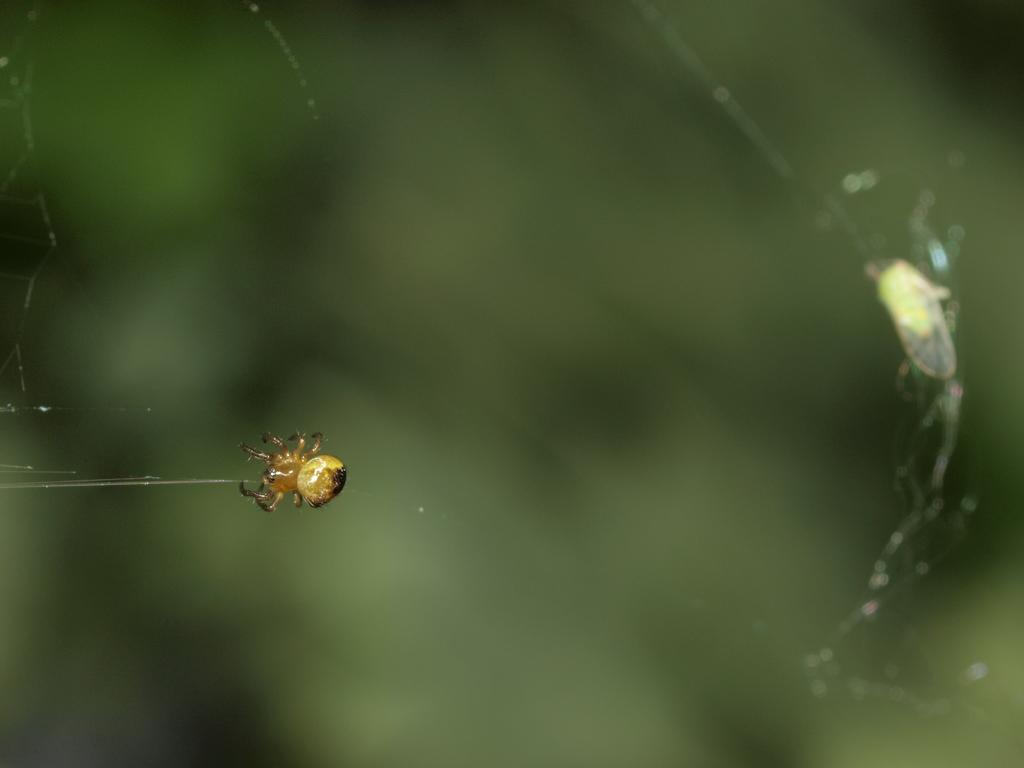What is the main subject of the image? There is a spider in the image. Where is the spider located? The spider is on a web. Can you describe the background of the image? The background of the image is blurry. What type of seat can be seen in the image? There is no seat present in the image; it features a spider on a web. What kind of yam is being cooked in the image? There is no yam or cooking activity present in the image. 